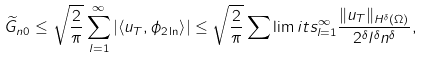<formula> <loc_0><loc_0><loc_500><loc_500>\widetilde { G } _ { n 0 } \leq \sqrt { \frac { 2 } { \pi } } \sum _ { l = 1 } ^ { \infty } \left | { \langle { u } _ { T } , { \phi _ { 2 \ln } } \rangle } \right | \leq \sqrt { \frac { 2 } { \pi } } \sum \lim i t s _ { l = 1 } ^ { \infty } \frac { \| { u } _ { T } \| _ { H ^ { \delta } ( \Omega ) } } { 2 ^ { \delta } l ^ { \delta } n ^ { \delta } } ,</formula> 